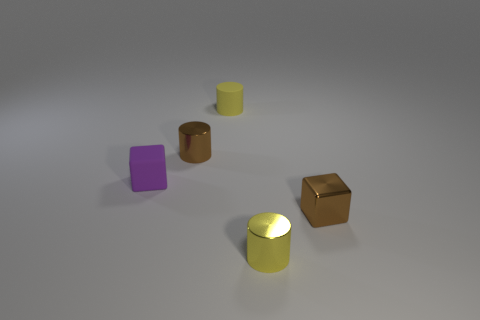There is a small purple thing; what shape is it?
Ensure brevity in your answer.  Cube. Is the number of matte blocks that are right of the tiny yellow matte cylinder greater than the number of cylinders that are behind the tiny purple rubber block?
Your answer should be compact. No. How many other things are there of the same size as the yellow shiny cylinder?
Make the answer very short. 4. There is a small thing that is to the left of the tiny matte cylinder and in front of the tiny brown cylinder; what material is it?
Give a very brief answer. Rubber. There is a brown thing that is the same shape as the yellow rubber object; what is its material?
Provide a short and direct response. Metal. How many tiny purple blocks are on the right side of the small cube left of the brown shiny thing behind the tiny purple matte cube?
Provide a succinct answer. 0. Is there anything else that has the same color as the rubber cube?
Provide a succinct answer. No. What number of objects are behind the small brown metallic cube and on the right side of the tiny purple object?
Make the answer very short. 2. There is a shiny cylinder in front of the tiny brown cylinder; is its size the same as the cube that is on the left side of the brown block?
Make the answer very short. Yes. What number of things are either tiny brown metal things that are in front of the tiny brown metal cylinder or brown cylinders?
Provide a succinct answer. 2. 